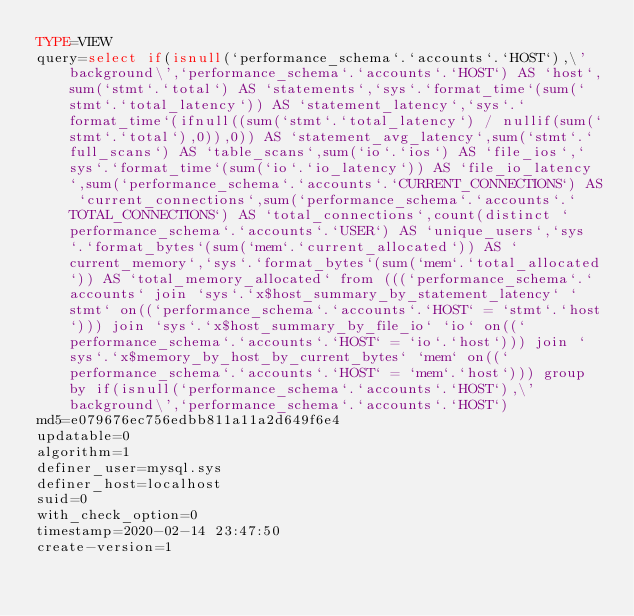<code> <loc_0><loc_0><loc_500><loc_500><_VisualBasic_>TYPE=VIEW
query=select if(isnull(`performance_schema`.`accounts`.`HOST`),\'background\',`performance_schema`.`accounts`.`HOST`) AS `host`,sum(`stmt`.`total`) AS `statements`,`sys`.`format_time`(sum(`stmt`.`total_latency`)) AS `statement_latency`,`sys`.`format_time`(ifnull((sum(`stmt`.`total_latency`) / nullif(sum(`stmt`.`total`),0)),0)) AS `statement_avg_latency`,sum(`stmt`.`full_scans`) AS `table_scans`,sum(`io`.`ios`) AS `file_ios`,`sys`.`format_time`(sum(`io`.`io_latency`)) AS `file_io_latency`,sum(`performance_schema`.`accounts`.`CURRENT_CONNECTIONS`) AS `current_connections`,sum(`performance_schema`.`accounts`.`TOTAL_CONNECTIONS`) AS `total_connections`,count(distinct `performance_schema`.`accounts`.`USER`) AS `unique_users`,`sys`.`format_bytes`(sum(`mem`.`current_allocated`)) AS `current_memory`,`sys`.`format_bytes`(sum(`mem`.`total_allocated`)) AS `total_memory_allocated` from (((`performance_schema`.`accounts` join `sys`.`x$host_summary_by_statement_latency` `stmt` on((`performance_schema`.`accounts`.`HOST` = `stmt`.`host`))) join `sys`.`x$host_summary_by_file_io` `io` on((`performance_schema`.`accounts`.`HOST` = `io`.`host`))) join `sys`.`x$memory_by_host_by_current_bytes` `mem` on((`performance_schema`.`accounts`.`HOST` = `mem`.`host`))) group by if(isnull(`performance_schema`.`accounts`.`HOST`),\'background\',`performance_schema`.`accounts`.`HOST`)
md5=e079676ec756edbb811a11a2d649f6e4
updatable=0
algorithm=1
definer_user=mysql.sys
definer_host=localhost
suid=0
with_check_option=0
timestamp=2020-02-14 23:47:50
create-version=1</code> 